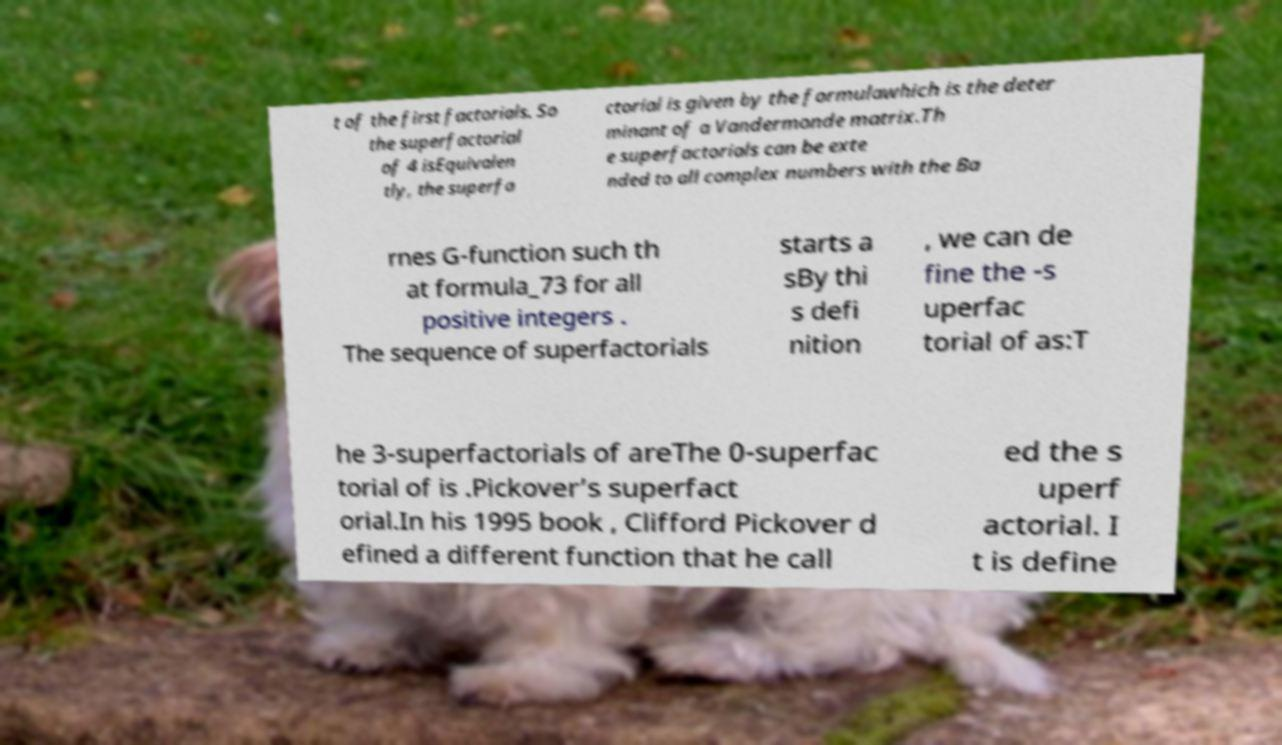There's text embedded in this image that I need extracted. Can you transcribe it verbatim? t of the first factorials. So the superfactorial of 4 isEquivalen tly, the superfa ctorial is given by the formulawhich is the deter minant of a Vandermonde matrix.Th e superfactorials can be exte nded to all complex numbers with the Ba rnes G-function such th at formula_73 for all positive integers . The sequence of superfactorials starts a sBy thi s defi nition , we can de fine the -s uperfac torial of as:T he 3-superfactorials of areThe 0-superfac torial of is .Pickover’s superfact orial.In his 1995 book , Clifford Pickover d efined a different function that he call ed the s uperf actorial. I t is define 